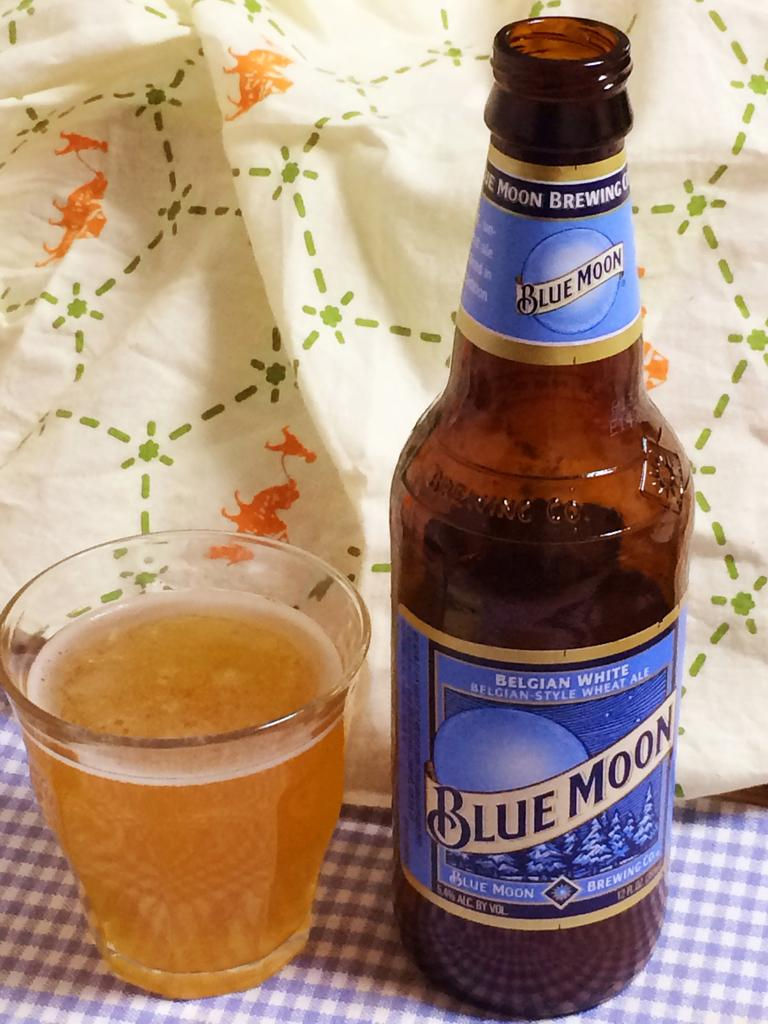<image>
Describe the image concisely. A bottle of Blue Moon beer on a checkered table next to a small glass 